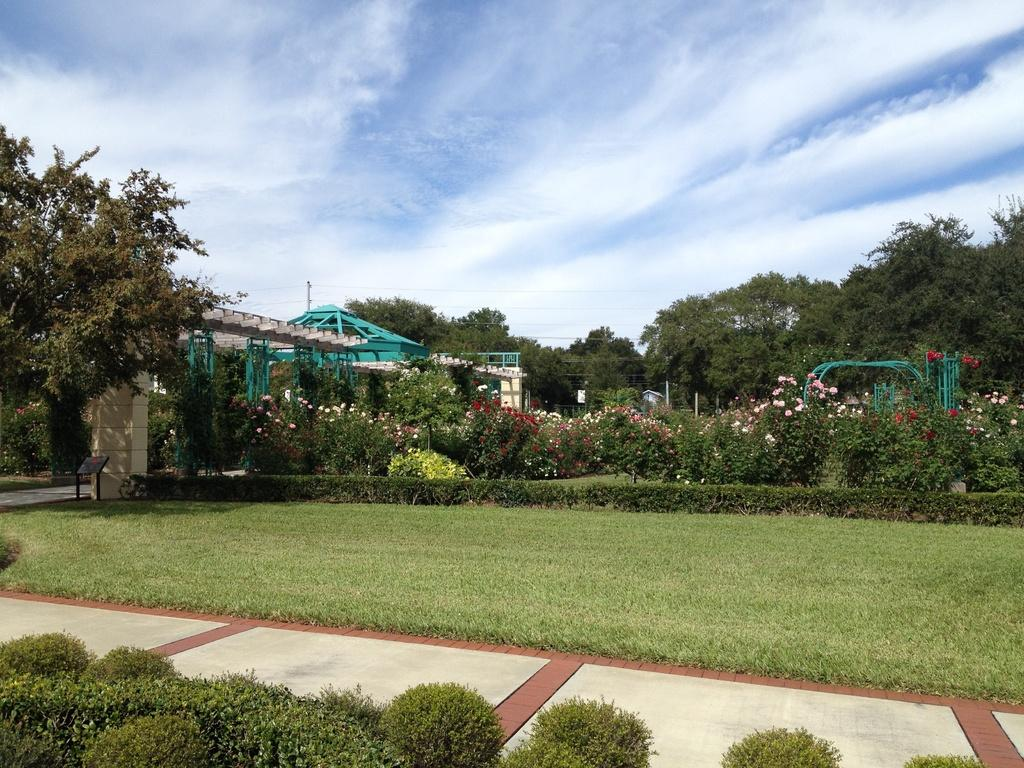What type of vegetation can be seen in the image? There is grass in the image. What is located beside the grass? There is a floor beside the grass. What type of plants are present in the image? There are plants with flowers in the image. What other natural elements can be seen in the image? There are trees in the image. What type of structure is visible in the image? There is a shed in the image. What is visible in the sky in the image? The sky is visible in the image, and there are clouds in the sky. How many ants can be seen crawling on the actor's head in the image? There are no ants or actors present in the image. What type of house is visible in the image? There is no house visible in the image; only a shed is present. 